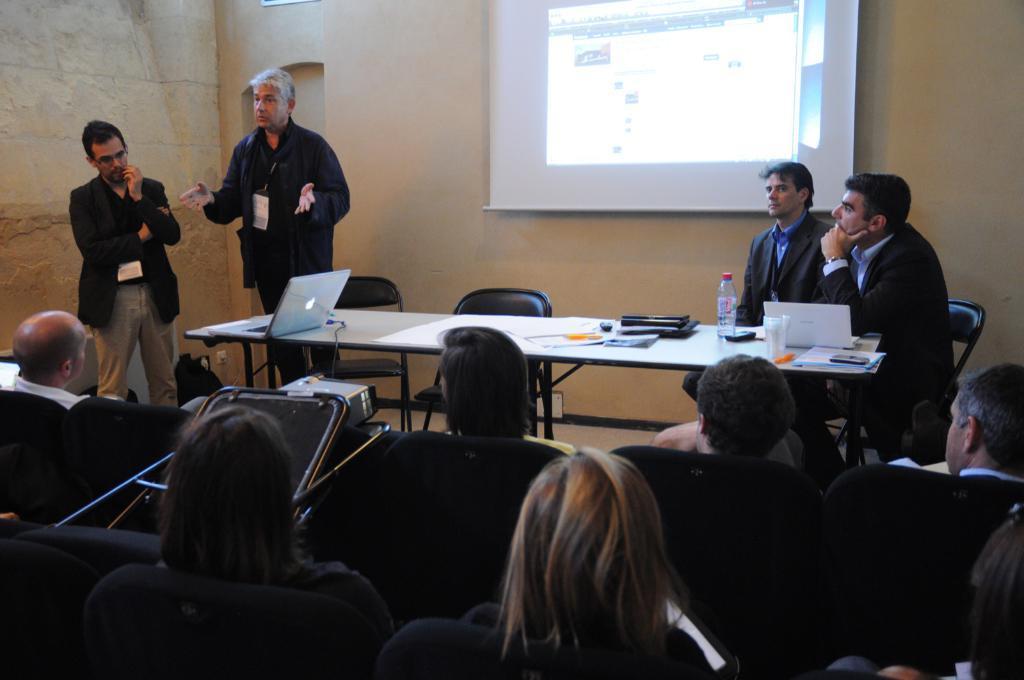Can you describe this image briefly? In the image we can see there are people sitting and two of them are standing, they are wearing clothes. There are many chairs and a table, on the table, we can see electronic devices, a bottle, glass and papers. Here we can see the cable wire, wall and the projected screen. 